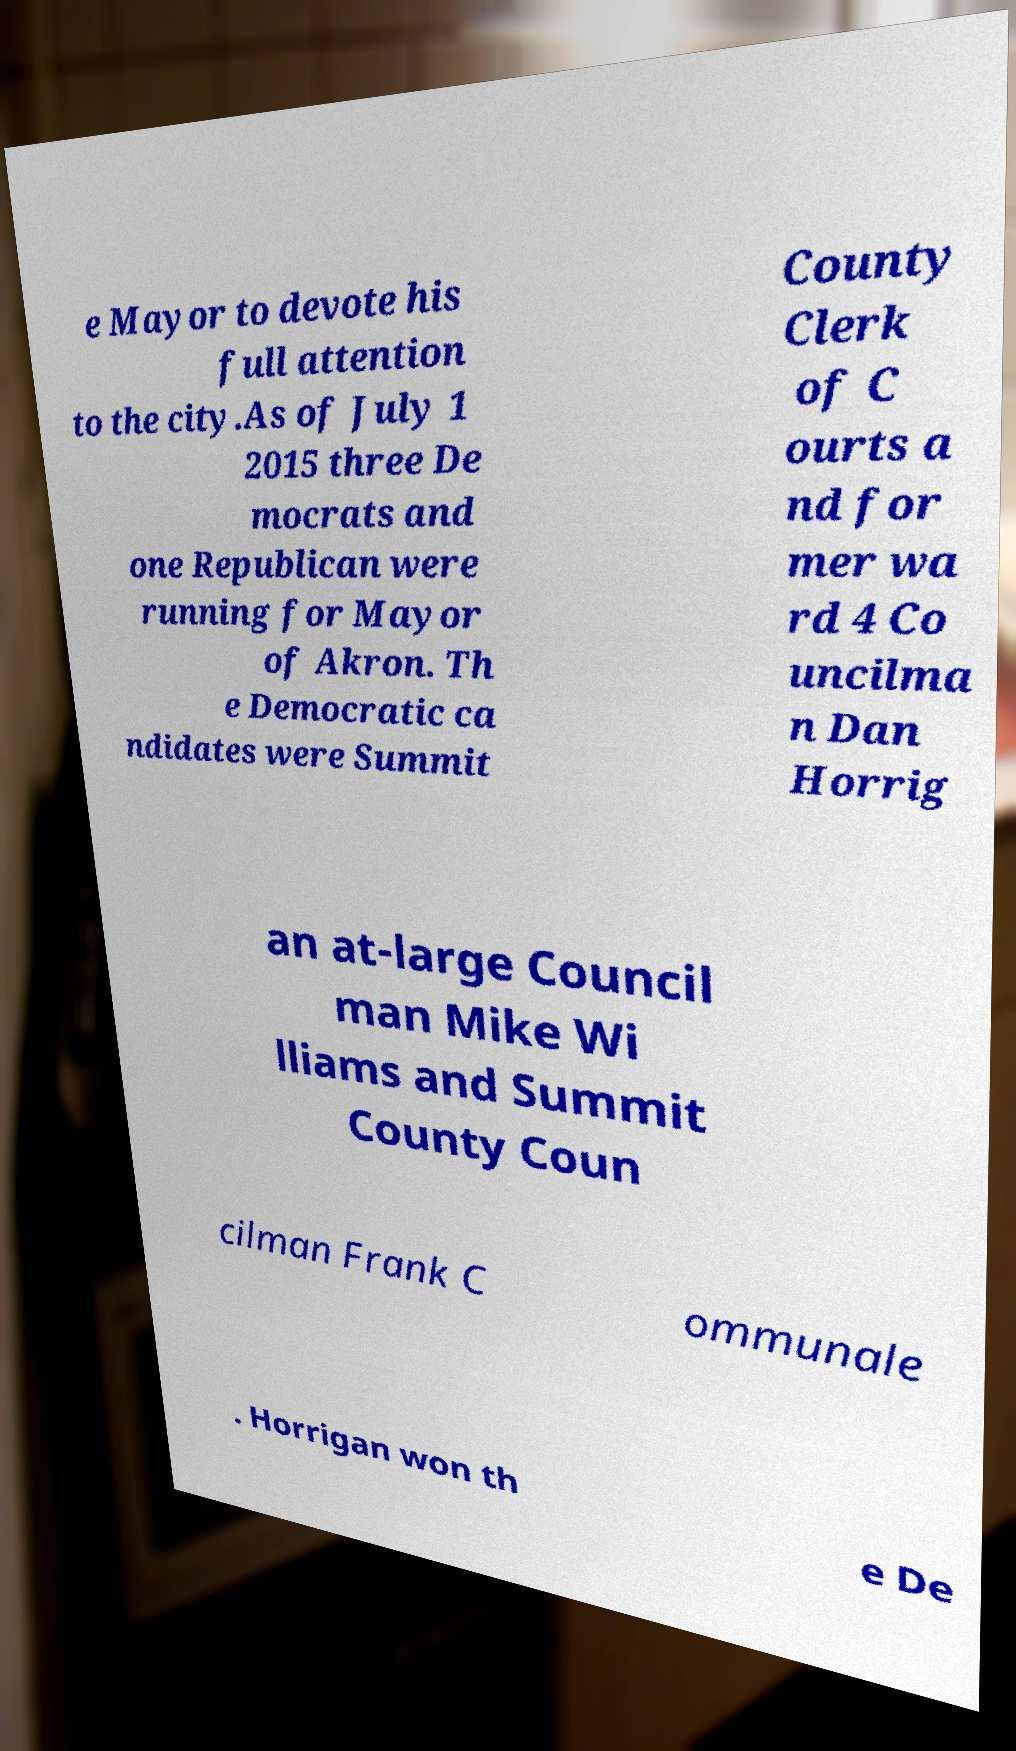Please identify and transcribe the text found in this image. e Mayor to devote his full attention to the city.As of July 1 2015 three De mocrats and one Republican were running for Mayor of Akron. Th e Democratic ca ndidates were Summit County Clerk of C ourts a nd for mer wa rd 4 Co uncilma n Dan Horrig an at-large Council man Mike Wi lliams and Summit County Coun cilman Frank C ommunale . Horrigan won th e De 